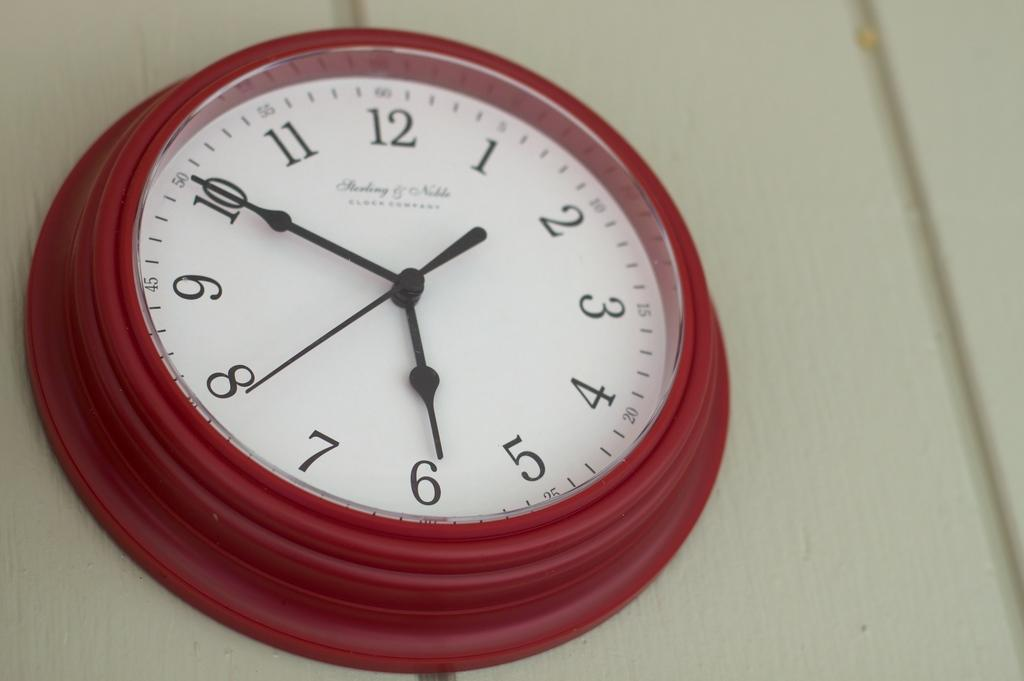<image>
Relay a brief, clear account of the picture shown. a red clock labeled as 'clock company' on it 